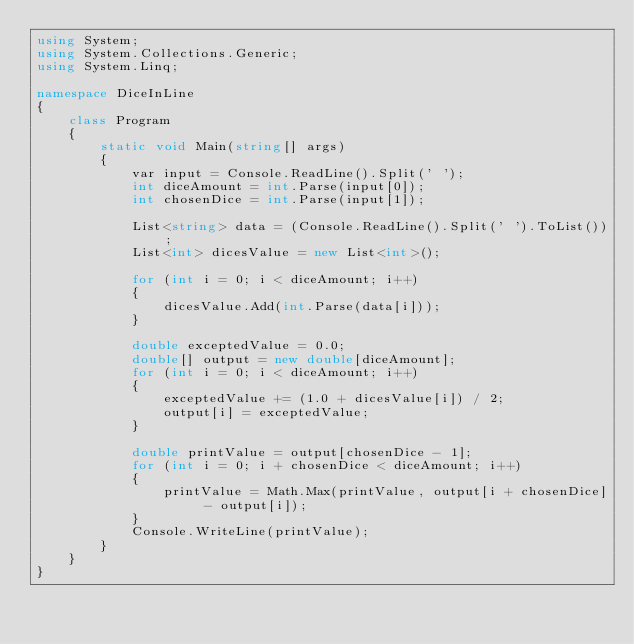Convert code to text. <code><loc_0><loc_0><loc_500><loc_500><_C#_>using System;
using System.Collections.Generic;
using System.Linq;
 
namespace DiceInLine
{
    class Program
    {
        static void Main(string[] args)
        {
            var input = Console.ReadLine().Split(' ');
            int diceAmount = int.Parse(input[0]);
            int chosenDice = int.Parse(input[1]);
 
            List<string> data = (Console.ReadLine().Split(' ').ToList());
            List<int> dicesValue = new List<int>();
 
            for (int i = 0; i < diceAmount; i++)
            {
                dicesValue.Add(int.Parse(data[i]));
            }
 
            double exceptedValue = 0.0;
            double[] output = new double[diceAmount];
            for (int i = 0; i < diceAmount; i++)
            {
                exceptedValue += (1.0 + dicesValue[i]) / 2;
                output[i] = exceptedValue;
            }
 
            double printValue = output[chosenDice - 1];            
            for (int i = 0; i + chosenDice < diceAmount; i++)
            {
                printValue = Math.Max(printValue, output[i + chosenDice] - output[i]);                
            }
            Console.WriteLine(printValue);            
        }
    }
}</code> 